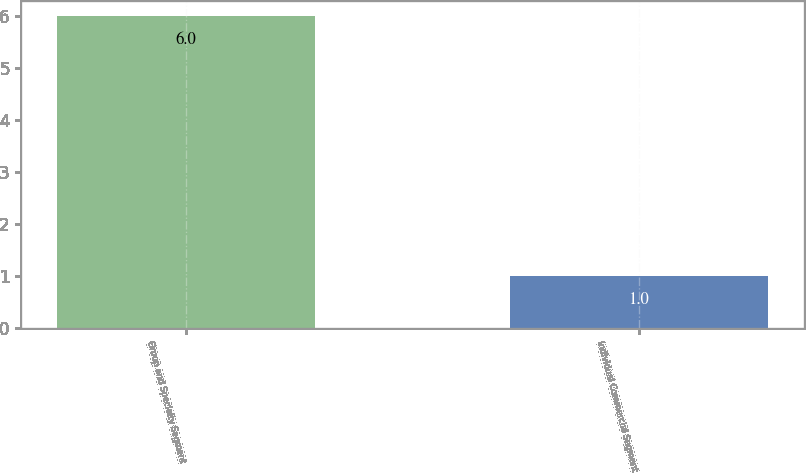Convert chart to OTSL. <chart><loc_0><loc_0><loc_500><loc_500><bar_chart><fcel>Group and Specialty Segment<fcel>Individual Commercial Segment<nl><fcel>6<fcel>1<nl></chart> 